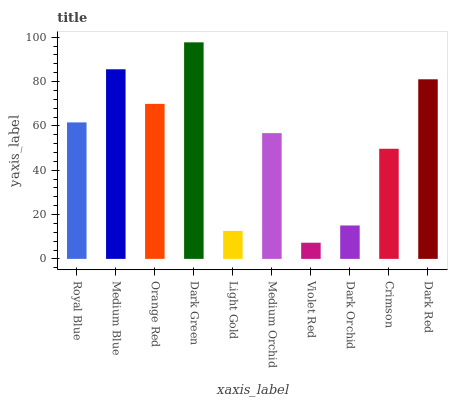Is Violet Red the minimum?
Answer yes or no. Yes. Is Dark Green the maximum?
Answer yes or no. Yes. Is Medium Blue the minimum?
Answer yes or no. No. Is Medium Blue the maximum?
Answer yes or no. No. Is Medium Blue greater than Royal Blue?
Answer yes or no. Yes. Is Royal Blue less than Medium Blue?
Answer yes or no. Yes. Is Royal Blue greater than Medium Blue?
Answer yes or no. No. Is Medium Blue less than Royal Blue?
Answer yes or no. No. Is Royal Blue the high median?
Answer yes or no. Yes. Is Medium Orchid the low median?
Answer yes or no. Yes. Is Light Gold the high median?
Answer yes or no. No. Is Dark Green the low median?
Answer yes or no. No. 